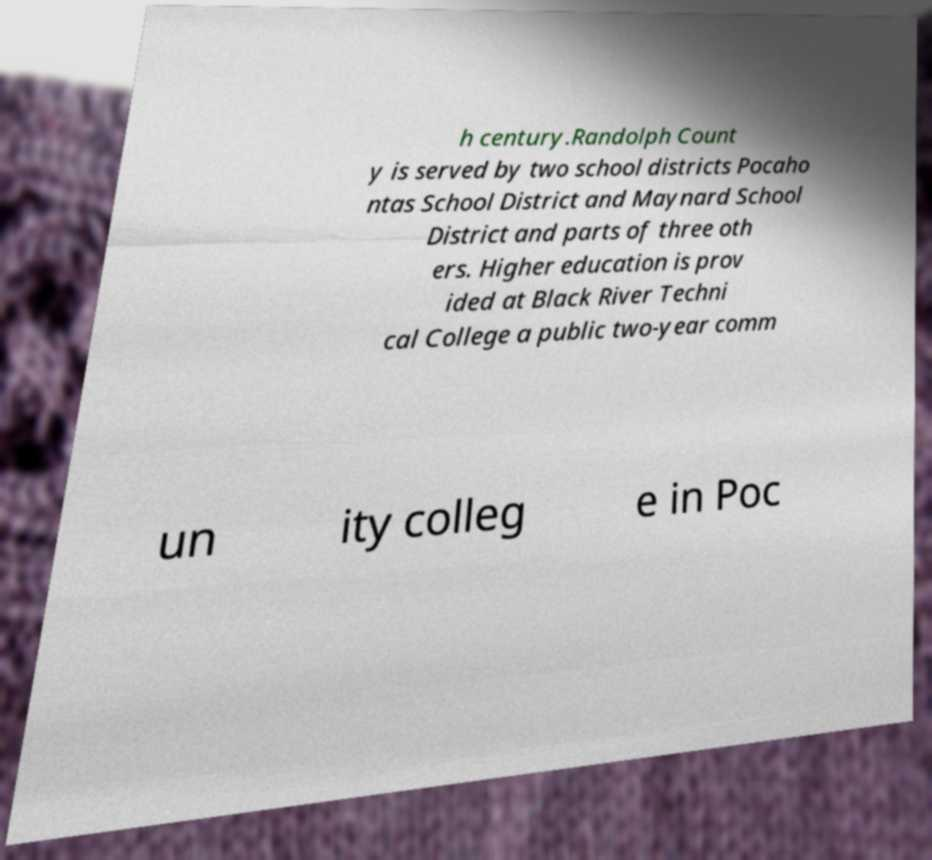For documentation purposes, I need the text within this image transcribed. Could you provide that? h century.Randolph Count y is served by two school districts Pocaho ntas School District and Maynard School District and parts of three oth ers. Higher education is prov ided at Black River Techni cal College a public two-year comm un ity colleg e in Poc 